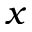<formula> <loc_0><loc_0><loc_500><loc_500>x</formula> 